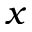<formula> <loc_0><loc_0><loc_500><loc_500>x</formula> 